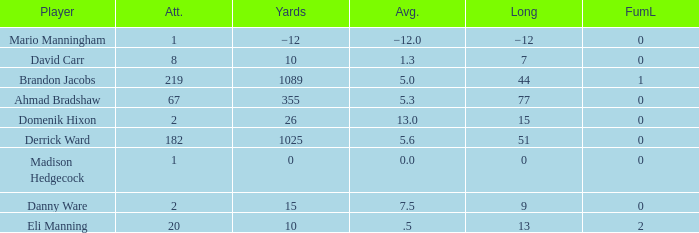What is Domenik Hixon's average rush? 13.0. 